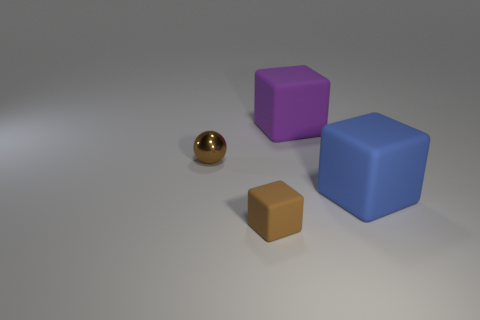Add 3 large purple matte objects. How many objects exist? 7 Subtract all balls. How many objects are left? 3 Subtract 0 cyan balls. How many objects are left? 4 Subtract all big spheres. Subtract all blue rubber cubes. How many objects are left? 3 Add 4 tiny brown spheres. How many tiny brown spheres are left? 5 Add 4 matte blocks. How many matte blocks exist? 7 